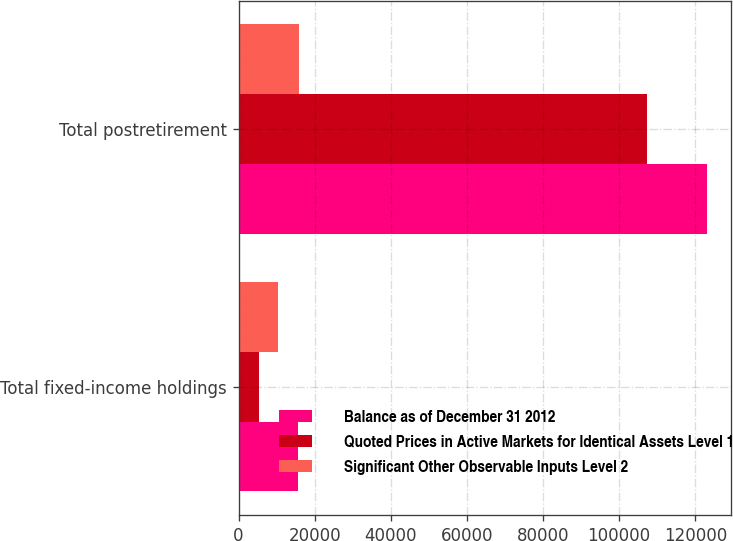Convert chart. <chart><loc_0><loc_0><loc_500><loc_500><stacked_bar_chart><ecel><fcel>Total fixed-income holdings<fcel>Total postretirement<nl><fcel>Balance as of December 31 2012<fcel>15684<fcel>123106<nl><fcel>Quoted Prices in Active Markets for Identical Assets Level 1<fcel>5370<fcel>107270<nl><fcel>Significant Other Observable Inputs Level 2<fcel>10314<fcel>15836<nl></chart> 